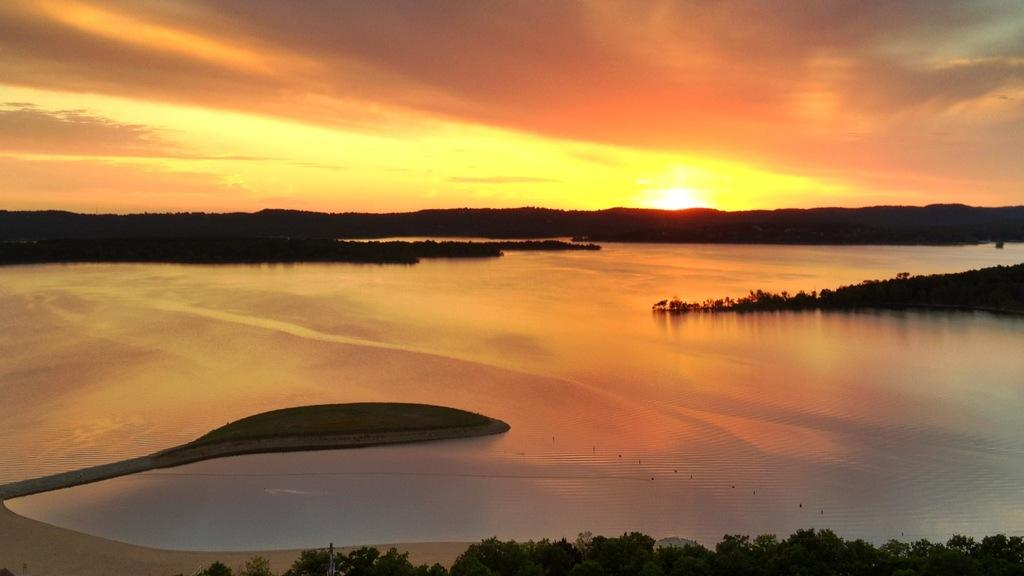What type of natural environment is depicted at the bottom of the image? There are trees and sand at the bottom of the image. What can be seen in the background of the image? There is water and trees visible in the background of the image. What is the condition of the sky in the image? The sky is visible in the image, and it contains the sun and clouds. What process is being carried out by the trees in the image? There is no process being carried out by the trees in the image; they are simply standing in the natural environment. How do the trees say good-bye to each other in the image? There is no interaction between the trees in the image, and therefore no good-byes are being exchanged. 